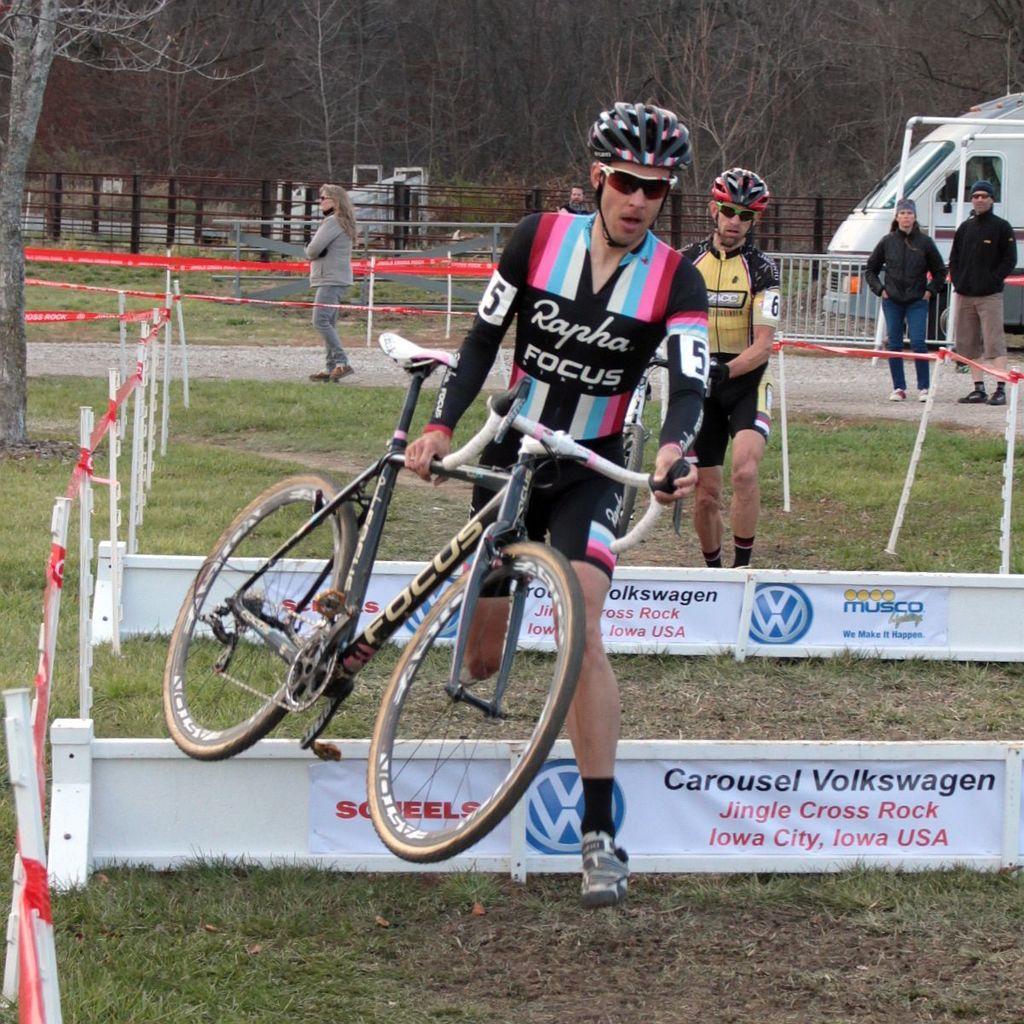Could you give a brief overview of what you see in this image? In this picture there is a man who is holding a bicycle, besides him I can see the small boards on the ground. Behind him there is another man who is also holding a bicycle and walking on the ground. In the back there is a woman who is standing near to the poles. On the right there are two persons who are standing near to the fencing and van. In the background I can see the trees, plants and dustbins. 